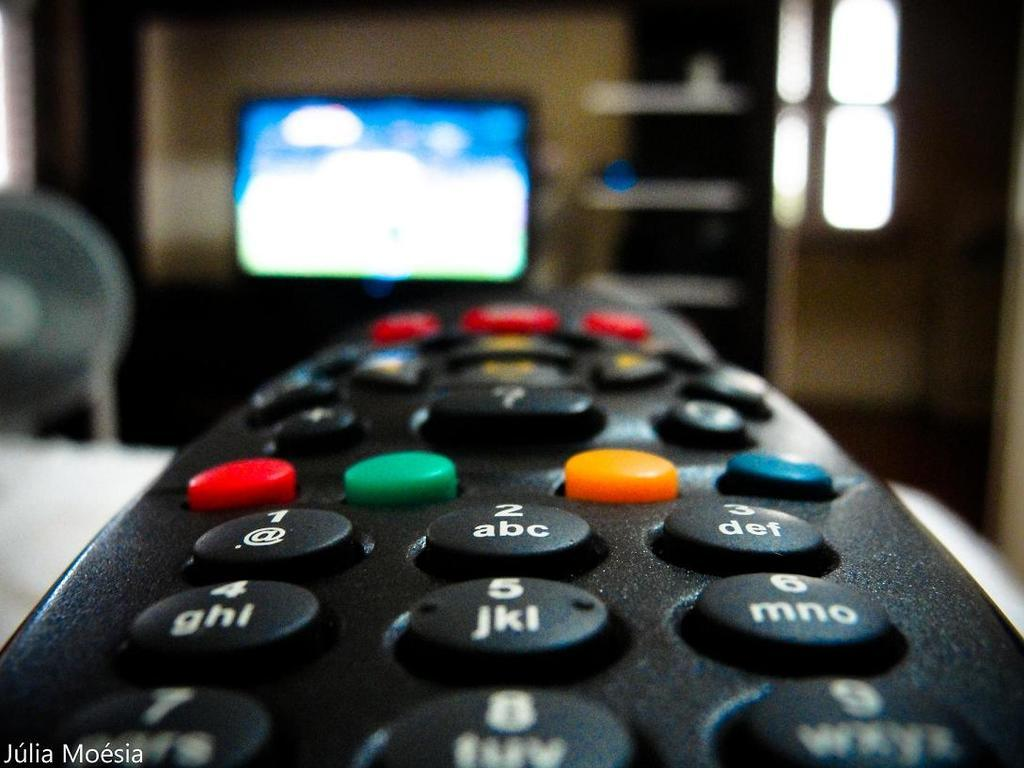<image>
Share a concise interpretation of the image provided. A photograph of a remote was taken by Julia Moesia. 